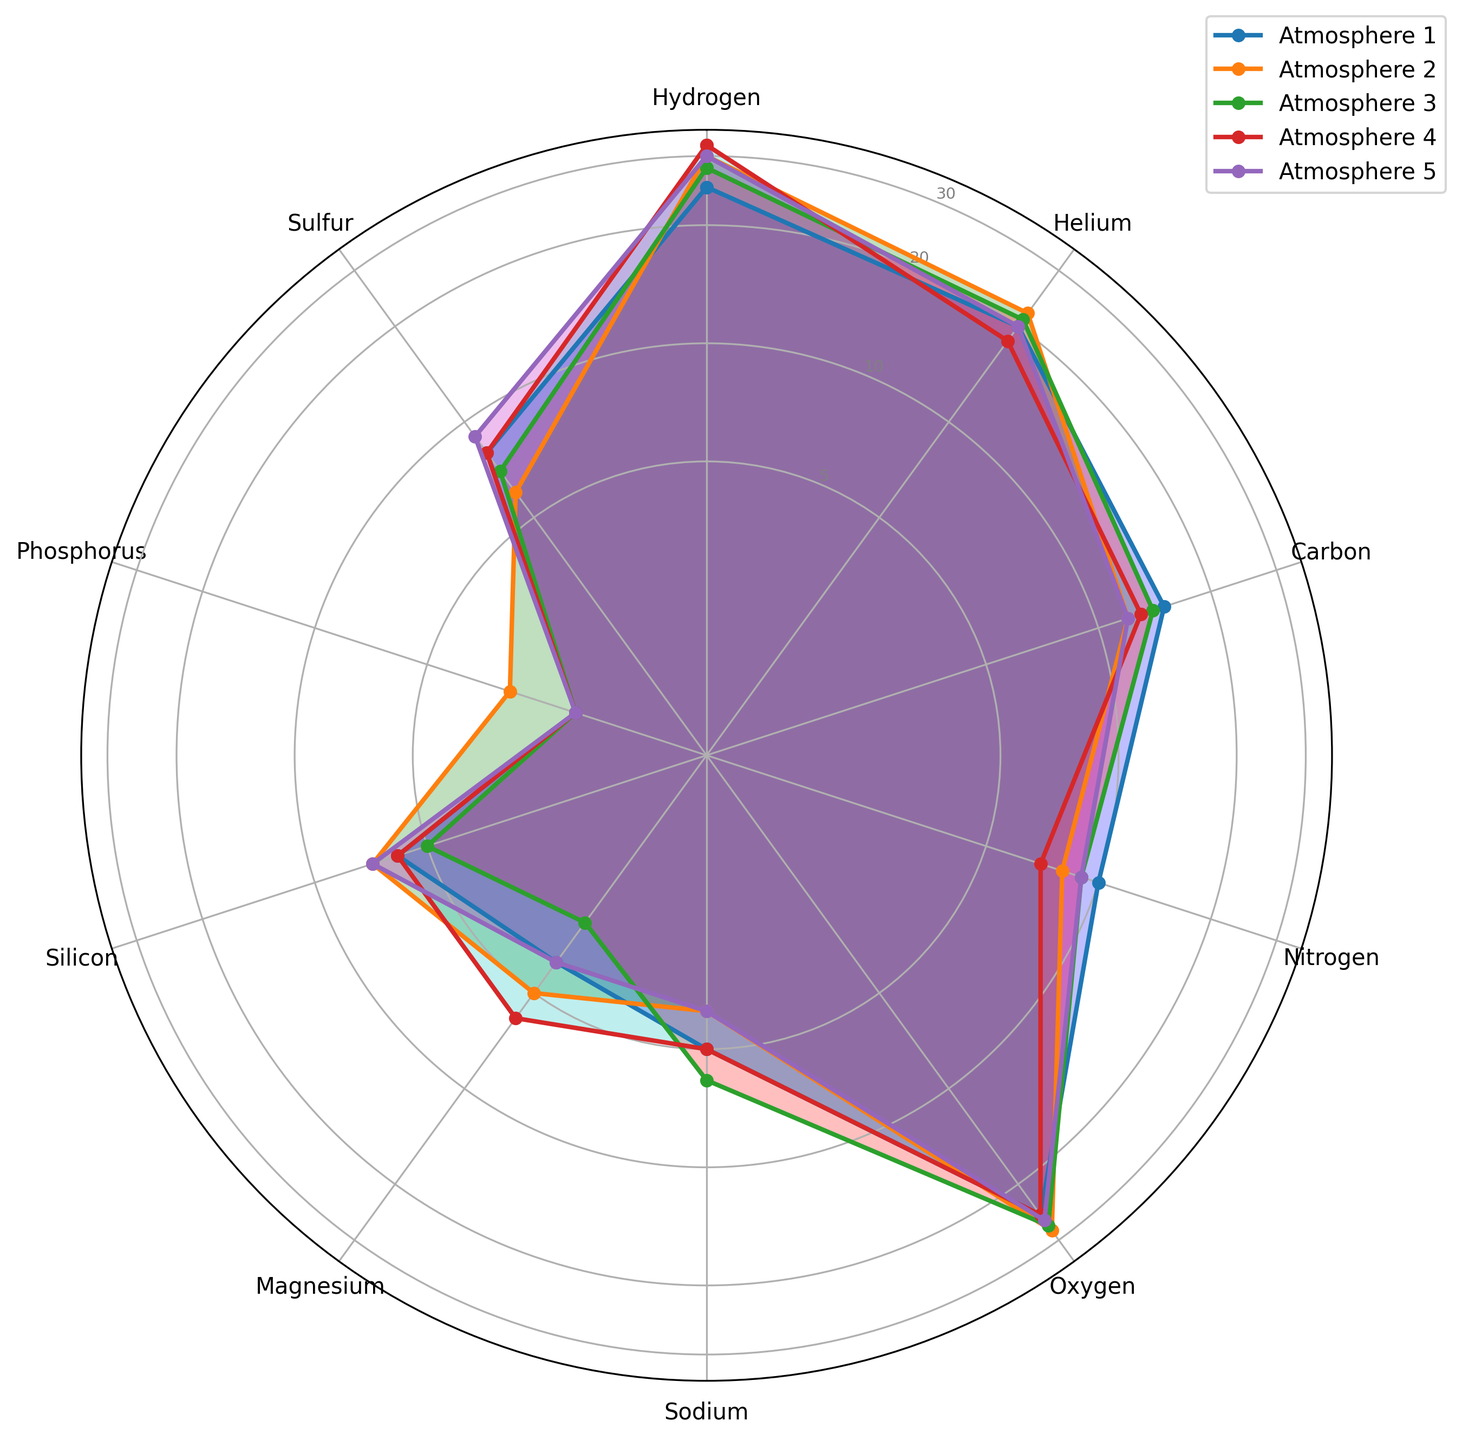Which atmosphere has the highest abundance of hydrogen? From the plot, observe the hydrogen values from different atmospheres. The purple line (Atmosphere 4) reaches the farthest from the center, indicating the highest abundance.
Answer: Atmosphere 4 What is the difference in oxygen abundance between Atmosphere 1 and Atmosphere 3? Look at the oxygen values on the radar chart. Oxygen count in Atmosphere 1 is 25, and in Atmosphere 3 is 27. The difference is 27 - 25.
Answer: 2 Which element has the lowest count across all atmospheres? From the chart, phosphorus consistently has the lowest values in all atmospheres when compared to other elements.
Answer: Phosphorus How does the hydrogen content in Atmosphere 2 compare with Atmosphere 5? Locate the radar chart lines for Atmosphere 2 and Atmosphere 5 on the hydrogen axis. Atmosphere 2 has a hydrogen count of 30, and Atmosphere 5 also has 30.
Answer: Equal What is the average count of sulfur in all atmospheres? The counts for sulfur are 8, 6, 7, 8, and 9. Summing these gives 8 + 6 + 7 + 8 + 9 = 38. Dividing by 5 gives the average, 38/5.
Answer: 7.6 Which element shows the most uniform distribution across all atmospheres? Compare the radar plot's lines' consistency for each element. Oxygen values barely deviate compared to others (values range from 25 to 28).
Answer: Oxygen Is the abundance of helium in Atmosphere 4 higher or lower than that in Atmosphere 1? Check the helium axis on the radar chart. Atmosphere 4 has a count of 18, while Atmosphere 1 has 20.
Answer: Lower What is the median count of sodium across all atmospheres? Sodium counts are 5, 4, 6, 5, and 4. Ordering them gives 4, 4, 5, 5, 6. The median value is the middle one in this ordered list.
Answer: 5 